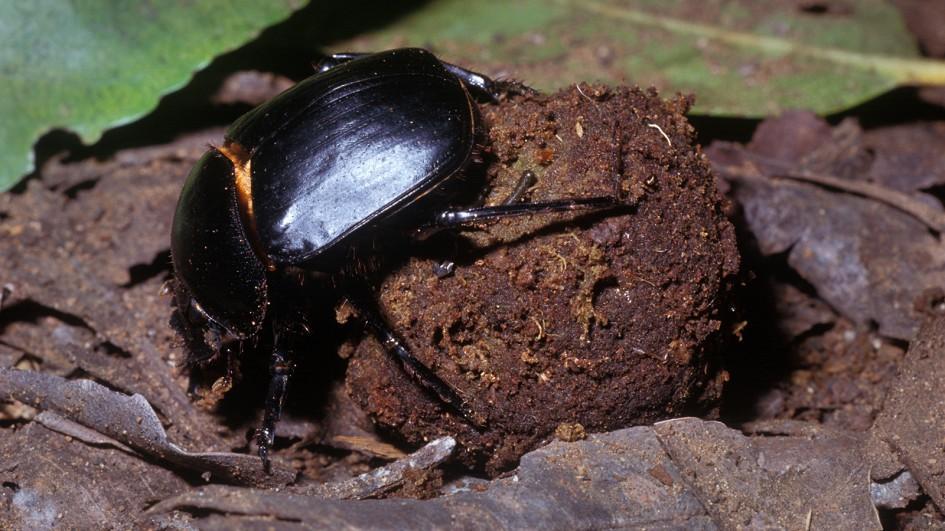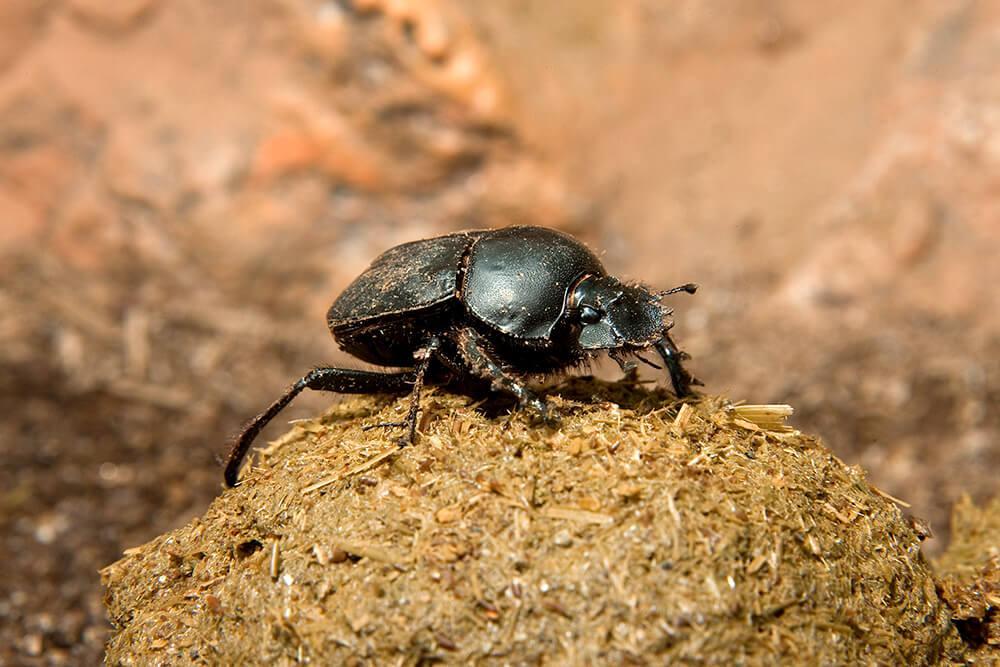The first image is the image on the left, the second image is the image on the right. Examine the images to the left and right. Is the description "Images show a total of two beetles and two dung balls." accurate? Answer yes or no. Yes. 